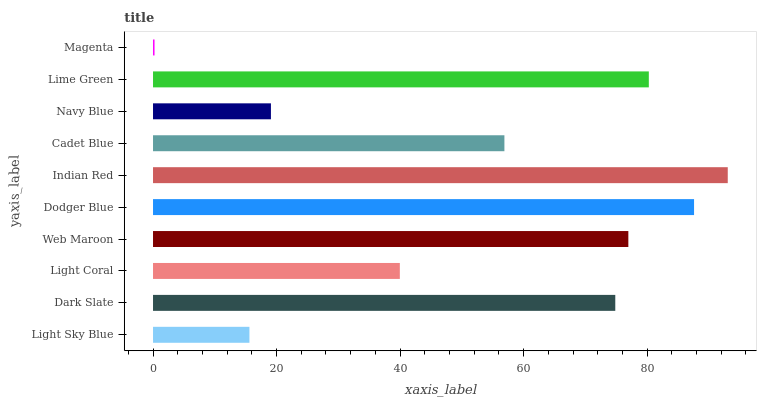Is Magenta the minimum?
Answer yes or no. Yes. Is Indian Red the maximum?
Answer yes or no. Yes. Is Dark Slate the minimum?
Answer yes or no. No. Is Dark Slate the maximum?
Answer yes or no. No. Is Dark Slate greater than Light Sky Blue?
Answer yes or no. Yes. Is Light Sky Blue less than Dark Slate?
Answer yes or no. Yes. Is Light Sky Blue greater than Dark Slate?
Answer yes or no. No. Is Dark Slate less than Light Sky Blue?
Answer yes or no. No. Is Dark Slate the high median?
Answer yes or no. Yes. Is Cadet Blue the low median?
Answer yes or no. Yes. Is Light Sky Blue the high median?
Answer yes or no. No. Is Light Sky Blue the low median?
Answer yes or no. No. 